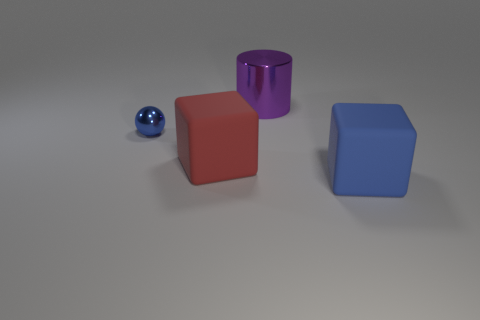Are any blue things visible?
Your answer should be compact. Yes. The big cube right of the metallic object behind the blue thing left of the big blue cube is what color?
Your answer should be compact. Blue. There is a blue object that is right of the big purple thing; is there a blue matte object in front of it?
Keep it short and to the point. No. There is a rubber object that is right of the big metal object; is it the same color as the metal object that is to the right of the small blue sphere?
Provide a succinct answer. No. What number of metallic spheres have the same size as the red thing?
Make the answer very short. 0. There is a blue thing to the left of the red rubber thing; is its size the same as the purple metal cylinder?
Offer a terse response. No. The small blue thing is what shape?
Your response must be concise. Sphere. The other object that is the same color as the small shiny thing is what size?
Provide a succinct answer. Large. Is the material of the block to the right of the large metal object the same as the tiny blue sphere?
Your answer should be compact. No. Are there any large matte blocks that have the same color as the tiny object?
Make the answer very short. Yes. 